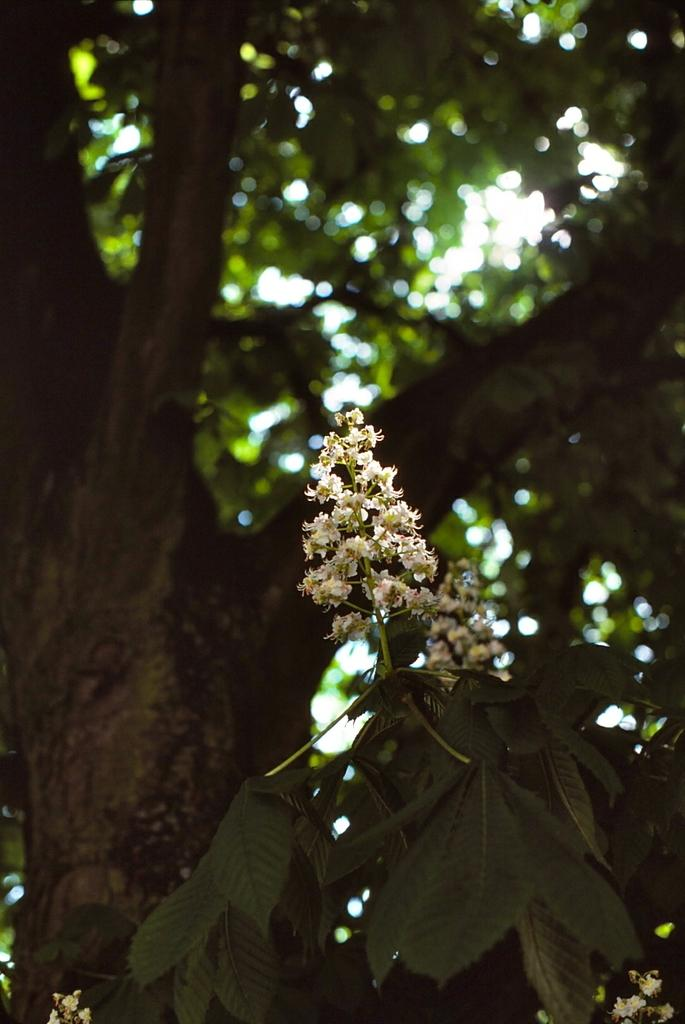What type of plant can be seen in the image? There is a tree in the image. What other type of plant can be seen in the image? There are flowers in the image. What type of produce is being sold on the table in the image? There is no table or produce present in the image; it only features a tree and flowers. What notes or information can be found in the notebook in the image? There is no notebook present in the image. 